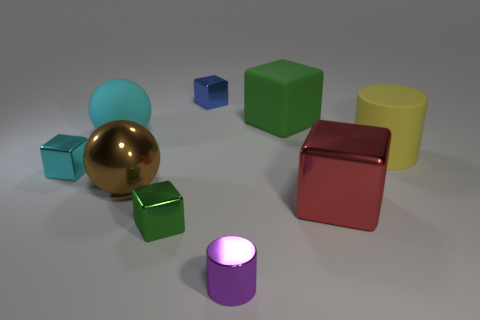Add 1 purple cylinders. How many objects exist? 10 Subtract all gray blocks. Subtract all purple spheres. How many blocks are left? 5 Subtract all blocks. How many objects are left? 4 Add 2 large things. How many large things are left? 7 Add 2 tiny metallic spheres. How many tiny metallic spheres exist? 2 Subtract 0 purple blocks. How many objects are left? 9 Subtract all green matte things. Subtract all green metallic things. How many objects are left? 7 